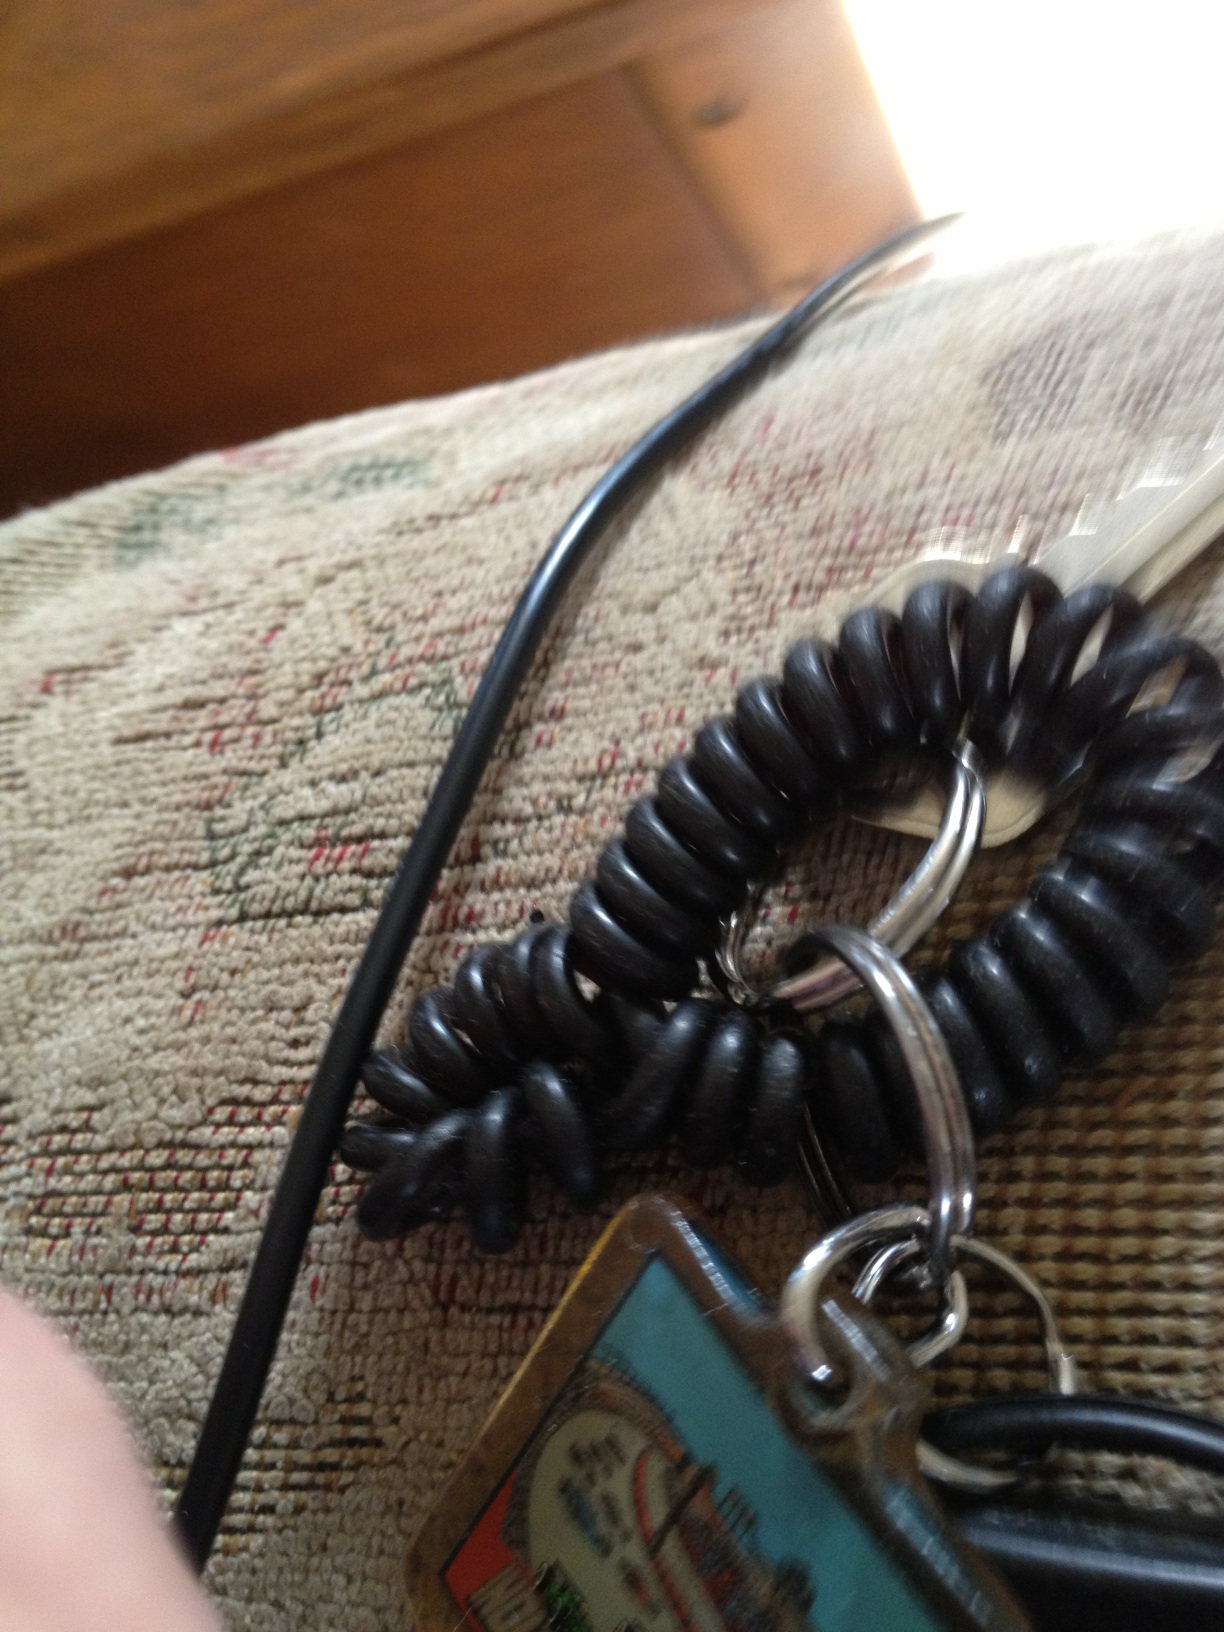Can you describe the details on this keychain? Certainly! The keychain includes a coiled black cord that likely provides flexibility, and there's a rectangular tag with a colorful design or image on it. It seems to also have several metallic rings holding various keys and items together. What is the purpose of the coiled black cord? The coiled black cord often serves to either provide additional length and flexibility, allowing the keys to stretch when used, or to help ensure that the keys are always retractable to a compact form when not in use. It can help in preventing the loss of keys as well by securing them to a larger object like a bag or belt. 